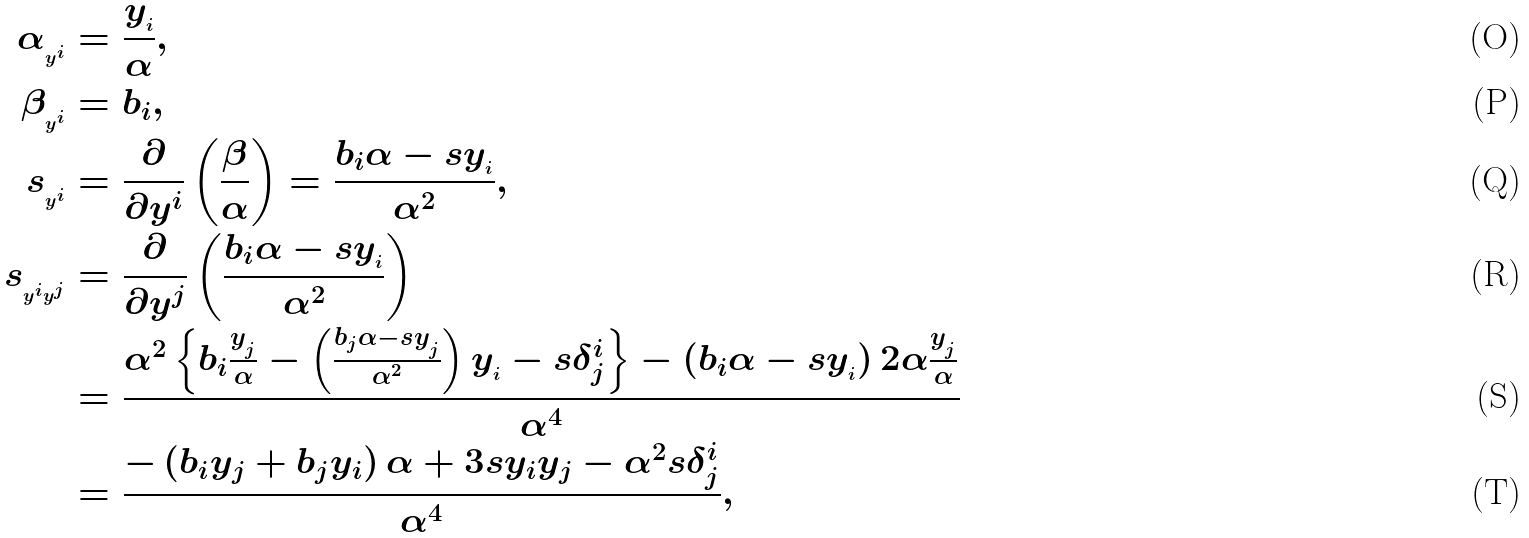Convert formula to latex. <formula><loc_0><loc_0><loc_500><loc_500>\alpha _ { _ { y ^ { i } } } & = \frac { y _ { _ { i } } } { \alpha } , \\ \beta _ { _ { y ^ { i } } } & = b _ { i } , \\ s _ { _ { y ^ { i } } } & = \frac { \partial } { \partial y ^ { i } } \left ( \frac { \beta } { \alpha } \right ) = \frac { b _ { i } \alpha - s y _ { _ { i } } } { \alpha ^ { 2 } } , \\ s _ { _ { y ^ { i } y ^ { j } } } & = \frac { \partial } { \partial y ^ { j } } \left ( \frac { b _ { i } \alpha - s y _ { _ { i } } } { \alpha ^ { 2 } } \right ) \\ & = \frac { \alpha ^ { 2 } \left \{ b _ { i } \frac { y _ { _ { j } } } { \alpha } - \left ( \frac { b _ { j } \alpha - s y _ { _ { j } } } { \alpha ^ { 2 } } \right ) y _ { _ { i } } - s \delta ^ { i } _ { j } \right \} - \left ( b _ { i } \alpha - s y _ { _ { i } } \right ) 2 \alpha \frac { y _ { _ { j } } } { \alpha } } { \alpha ^ { 4 } } \\ & = \frac { - \left ( b _ { i } y _ { j } + b _ { j } y _ { i } \right ) \alpha + 3 s y _ { i } y _ { j } - \alpha ^ { 2 } s \delta ^ { i } _ { j } } { \alpha ^ { 4 } } ,</formula> 